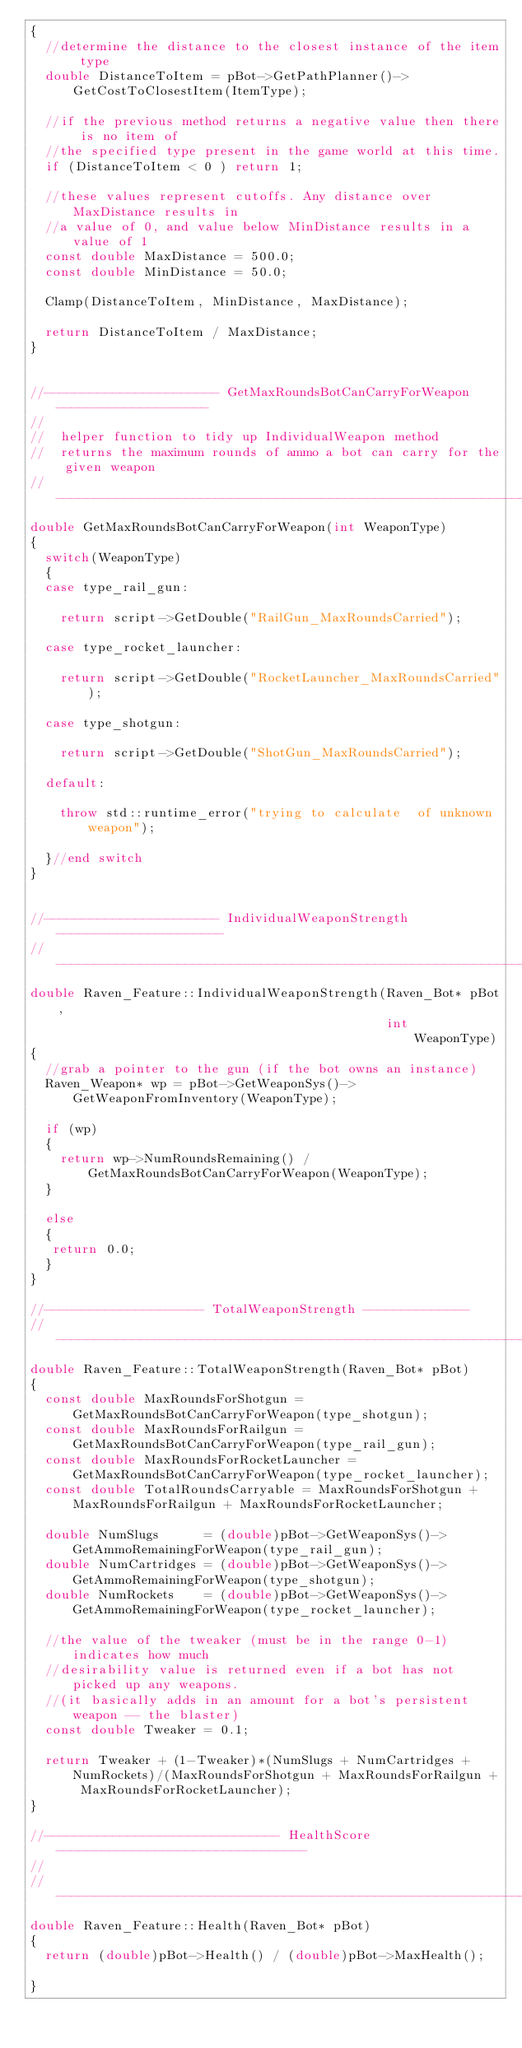Convert code to text. <code><loc_0><loc_0><loc_500><loc_500><_C++_>{
  //determine the distance to the closest instance of the item type
  double DistanceToItem = pBot->GetPathPlanner()->GetCostToClosestItem(ItemType);

  //if the previous method returns a negative value then there is no item of
  //the specified type present in the game world at this time.
  if (DistanceToItem < 0 ) return 1;

  //these values represent cutoffs. Any distance over MaxDistance results in
  //a value of 0, and value below MinDistance results in a value of 1
  const double MaxDistance = 500.0;
  const double MinDistance = 50.0;

  Clamp(DistanceToItem, MinDistance, MaxDistance);

  return DistanceToItem / MaxDistance;
}


//----------------------- GetMaxRoundsBotCanCarryForWeapon --------------------
//
//  helper function to tidy up IndividualWeapon method
//  returns the maximum rounds of ammo a bot can carry for the given weapon
//-----------------------------------------------------------------------------
double GetMaxRoundsBotCanCarryForWeapon(int WeaponType)
{
  switch(WeaponType)
  {
  case type_rail_gun:

    return script->GetDouble("RailGun_MaxRoundsCarried");

  case type_rocket_launcher:

    return script->GetDouble("RocketLauncher_MaxRoundsCarried");

  case type_shotgun:

    return script->GetDouble("ShotGun_MaxRoundsCarried");

  default:

    throw std::runtime_error("trying to calculate  of unknown weapon");

  }//end switch
}


//----------------------- IndividualWeaponStrength ----------------------
//-----------------------------------------------------------------------------
double Raven_Feature::IndividualWeaponStrength(Raven_Bot* pBot,
                                               int        WeaponType)
{
  //grab a pointer to the gun (if the bot owns an instance)
  Raven_Weapon* wp = pBot->GetWeaponSys()->GetWeaponFromInventory(WeaponType);

  if (wp)
  {
    return wp->NumRoundsRemaining() / GetMaxRoundsBotCanCarryForWeapon(WeaponType);
  }

  else
  {
   return 0.0;
  }
}

//--------------------- TotalWeaponStrength --------------
//-----------------------------------------------------------------------------
double Raven_Feature::TotalWeaponStrength(Raven_Bot* pBot)
{
  const double MaxRoundsForShotgun = GetMaxRoundsBotCanCarryForWeapon(type_shotgun);
  const double MaxRoundsForRailgun = GetMaxRoundsBotCanCarryForWeapon(type_rail_gun);
  const double MaxRoundsForRocketLauncher = GetMaxRoundsBotCanCarryForWeapon(type_rocket_launcher);
  const double TotalRoundsCarryable = MaxRoundsForShotgun + MaxRoundsForRailgun + MaxRoundsForRocketLauncher;

  double NumSlugs      = (double)pBot->GetWeaponSys()->GetAmmoRemainingForWeapon(type_rail_gun);
  double NumCartridges = (double)pBot->GetWeaponSys()->GetAmmoRemainingForWeapon(type_shotgun);
  double NumRockets    = (double)pBot->GetWeaponSys()->GetAmmoRemainingForWeapon(type_rocket_launcher);

  //the value of the tweaker (must be in the range 0-1) indicates how much
  //desirability value is returned even if a bot has not picked up any weapons.
  //(it basically adds in an amount for a bot's persistent weapon -- the blaster)
  const double Tweaker = 0.1;

  return Tweaker + (1-Tweaker)*(NumSlugs + NumCartridges + NumRockets)/(MaxRoundsForShotgun + MaxRoundsForRailgun + MaxRoundsForRocketLauncher);
}

//------------------------------- HealthScore ---------------------------------
//
//-----------------------------------------------------------------------------
double Raven_Feature::Health(Raven_Bot* pBot)
{
  return (double)pBot->Health() / (double)pBot->MaxHealth();

}</code> 